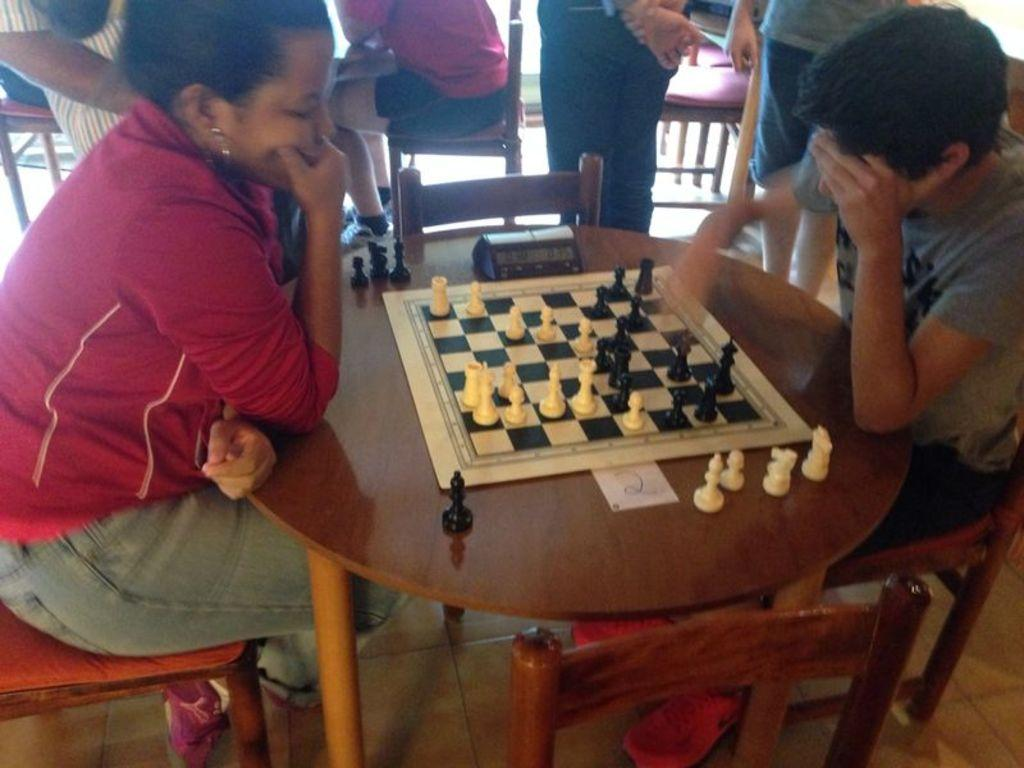How many people are in the image? There are two persons in the image. What are the persons doing in the image? The persons are sitting on chairs. What is in front of the chairs? There is a table in front of the chairs. What game is being played in the image? There are chess coins and a chess board in the image, indicating that they are playing chess. Can you describe the background of the image? There are people and chairs in the background of the image. What type of scent can be smelled coming from the houses in the image? There are no houses present in the image, so it is not possible to determine any scents. 